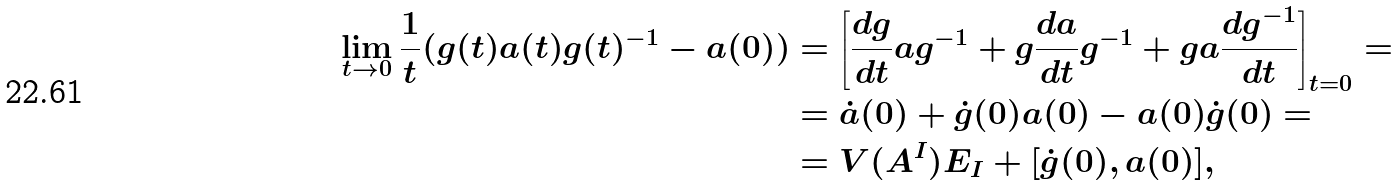<formula> <loc_0><loc_0><loc_500><loc_500>\lim _ { t \rightarrow 0 } \frac { 1 } { t } ( g ( t ) a ( t ) g ( t ) ^ { - 1 } - a ( 0 ) ) & = \left [ \frac { d g } { d t } a g ^ { - 1 } + g \frac { d a } { d t } g ^ { - 1 } + g a \frac { d g ^ { - 1 } } { d t } \right ] _ { t = 0 } = \\ & = \dot { a } ( 0 ) + \dot { g } ( 0 ) a ( 0 ) - a ( 0 ) \dot { g } ( 0 ) = \\ & = V ( A ^ { I } ) E _ { I } + [ \dot { g } ( 0 ) , a ( 0 ) ] ,</formula> 